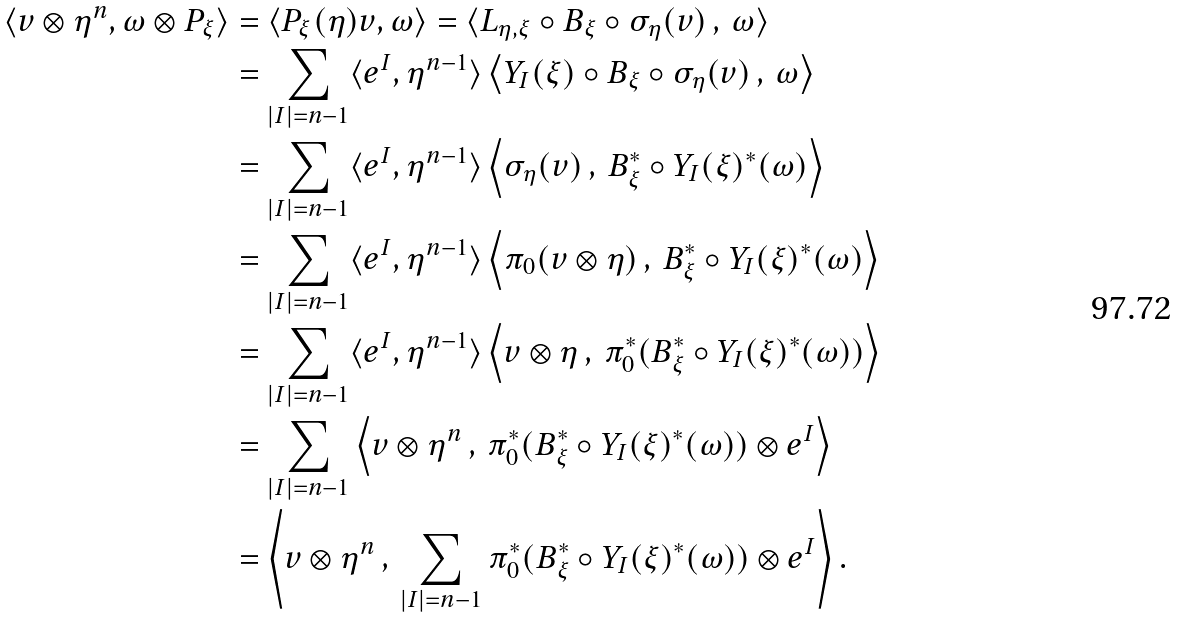<formula> <loc_0><loc_0><loc_500><loc_500>\langle v \otimes \eta ^ { n } , \omega \otimes P _ { \xi } \rangle & = \langle P _ { \xi } ( \eta ) v , \omega \rangle = \langle L _ { \eta , \xi } \circ B _ { \xi } \circ \sigma _ { \eta } ( v ) \, , \, \omega \rangle \\ & = \sum _ { | I | = n - 1 } \langle e ^ { I } , \eta ^ { n - 1 } \rangle \left \langle Y _ { I } ( \xi ) \circ B _ { \xi } \circ \sigma _ { \eta } ( v ) \, , \, \omega \right \rangle \\ & = \sum _ { | I | = n - 1 } \langle e ^ { I } , \eta ^ { n - 1 } \rangle \left \langle \sigma _ { \eta } ( v ) \, , \, B _ { \xi } ^ { * } \circ Y _ { I } ( \xi ) ^ { * } ( \omega ) \right \rangle \\ & = \sum _ { | I | = n - 1 } \langle e ^ { I } , \eta ^ { n - 1 } \rangle \left \langle \pi _ { 0 } ( v \otimes \eta ) \, , \, B _ { \xi } ^ { * } \circ Y _ { I } ( \xi ) ^ { * } ( \omega ) \right \rangle \\ & = \sum _ { | I | = n - 1 } \langle e ^ { I } , \eta ^ { n - 1 } \rangle \left \langle v \otimes \eta \, , \, \pi _ { 0 } ^ { * } ( B _ { \xi } ^ { * } \circ Y _ { I } ( \xi ) ^ { * } ( \omega ) ) \right \rangle \\ & = \sum _ { | I | = n - 1 } \left \langle v \otimes \eta ^ { n } \, , \, \pi _ { 0 } ^ { * } ( B _ { \xi } ^ { * } \circ Y _ { I } ( \xi ) ^ { * } ( \omega ) ) \otimes e ^ { I } \right \rangle \\ & = \left \langle v \otimes \eta ^ { n } \, , \, \sum _ { | I | = n - 1 } \pi _ { 0 } ^ { * } ( B _ { \xi } ^ { * } \circ Y _ { I } ( \xi ) ^ { * } ( \omega ) ) \otimes e ^ { I } \right \rangle .</formula> 